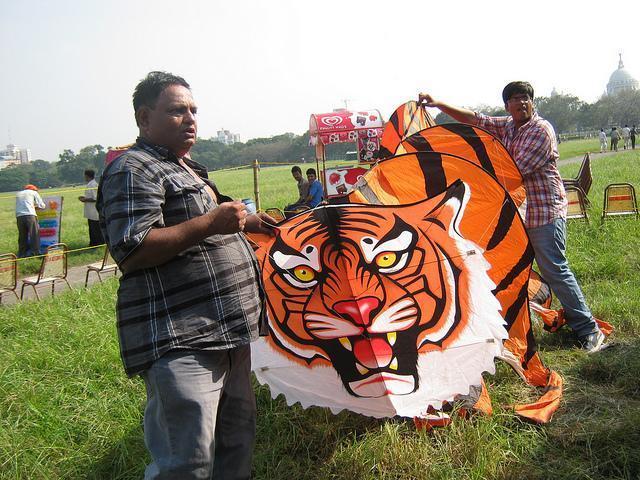How many people are in the photo?
Give a very brief answer. 2. 